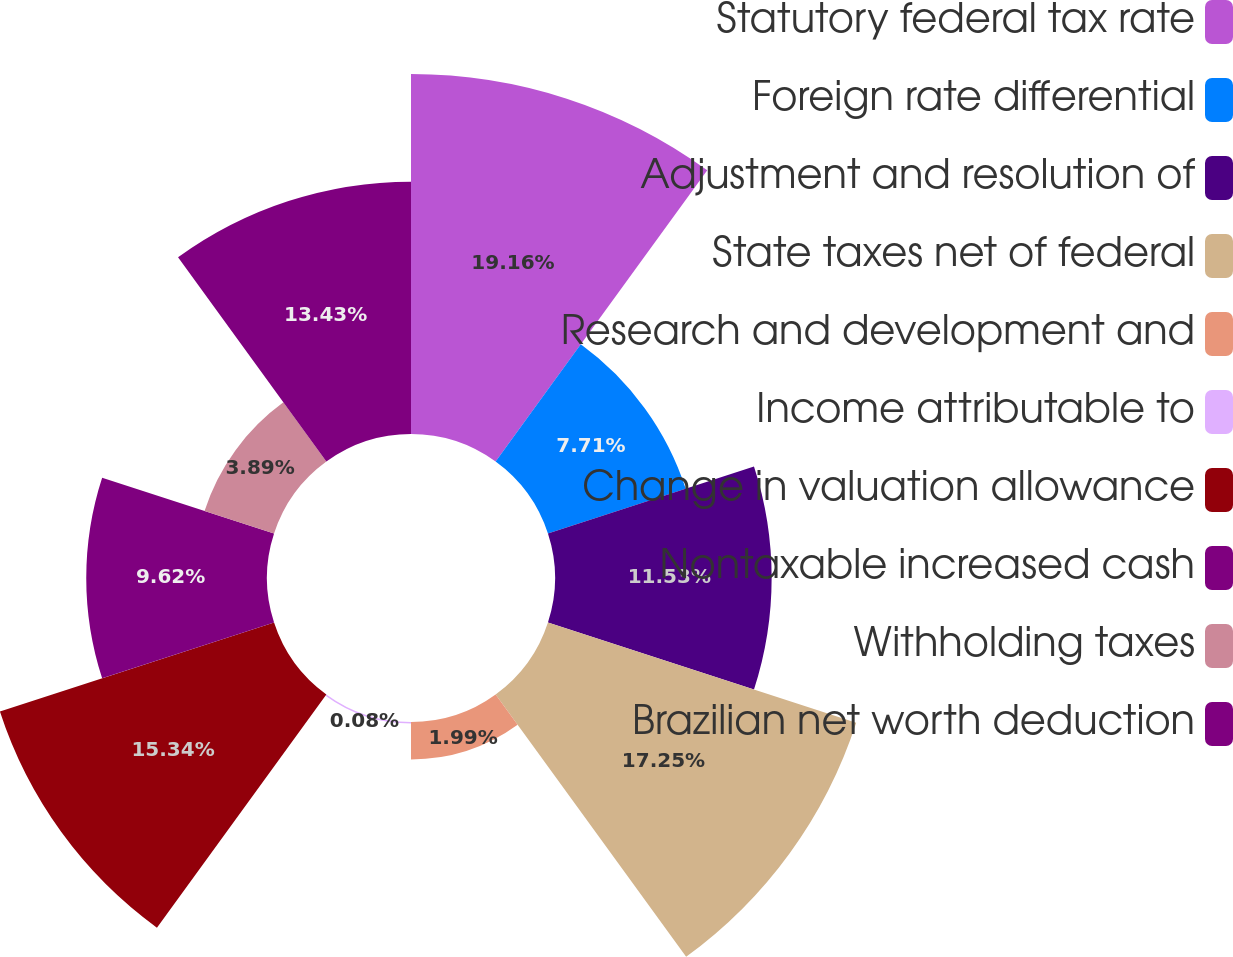Convert chart. <chart><loc_0><loc_0><loc_500><loc_500><pie_chart><fcel>Statutory federal tax rate<fcel>Foreign rate differential<fcel>Adjustment and resolution of<fcel>State taxes net of federal<fcel>Research and development and<fcel>Income attributable to<fcel>Change in valuation allowance<fcel>Nontaxable increased cash<fcel>Withholding taxes<fcel>Brazilian net worth deduction<nl><fcel>19.16%<fcel>7.71%<fcel>11.53%<fcel>17.25%<fcel>1.99%<fcel>0.08%<fcel>15.34%<fcel>9.62%<fcel>3.89%<fcel>13.43%<nl></chart> 